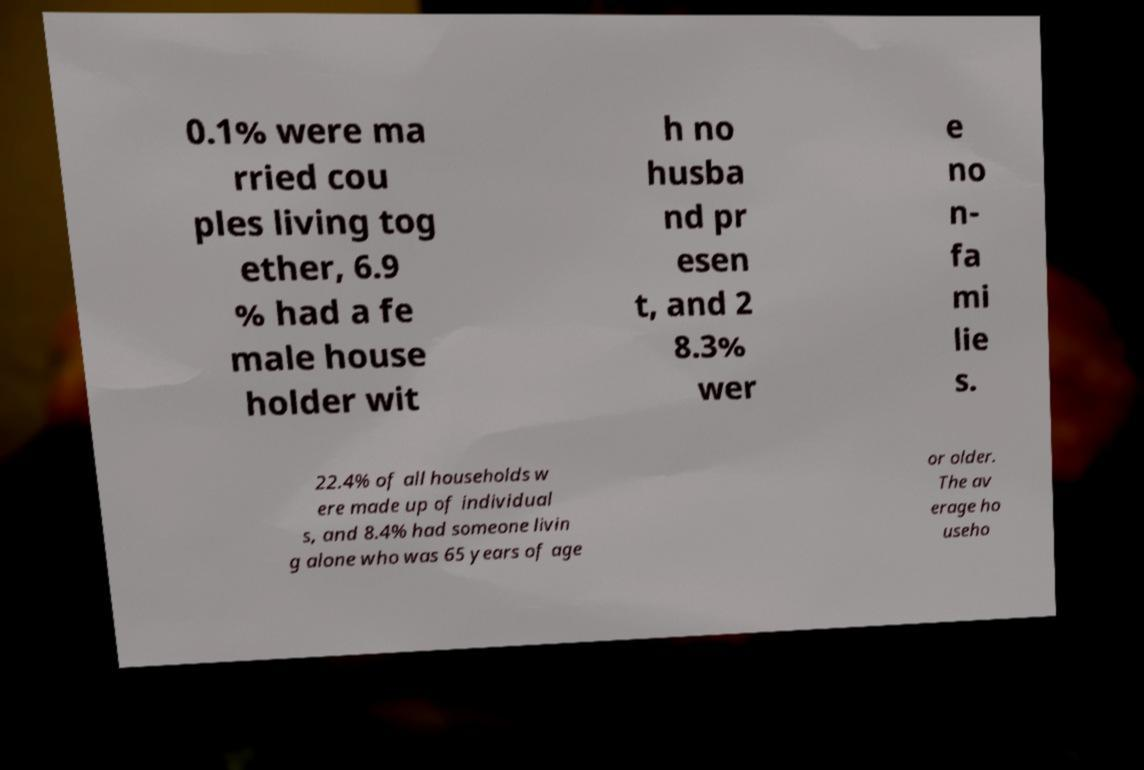What messages or text are displayed in this image? I need them in a readable, typed format. 0.1% were ma rried cou ples living tog ether, 6.9 % had a fe male house holder wit h no husba nd pr esen t, and 2 8.3% wer e no n- fa mi lie s. 22.4% of all households w ere made up of individual s, and 8.4% had someone livin g alone who was 65 years of age or older. The av erage ho useho 